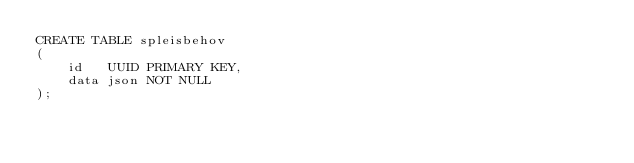Convert code to text. <code><loc_0><loc_0><loc_500><loc_500><_SQL_>CREATE TABLE spleisbehov
(
    id   UUID PRIMARY KEY,
    data json NOT NULL
);
</code> 